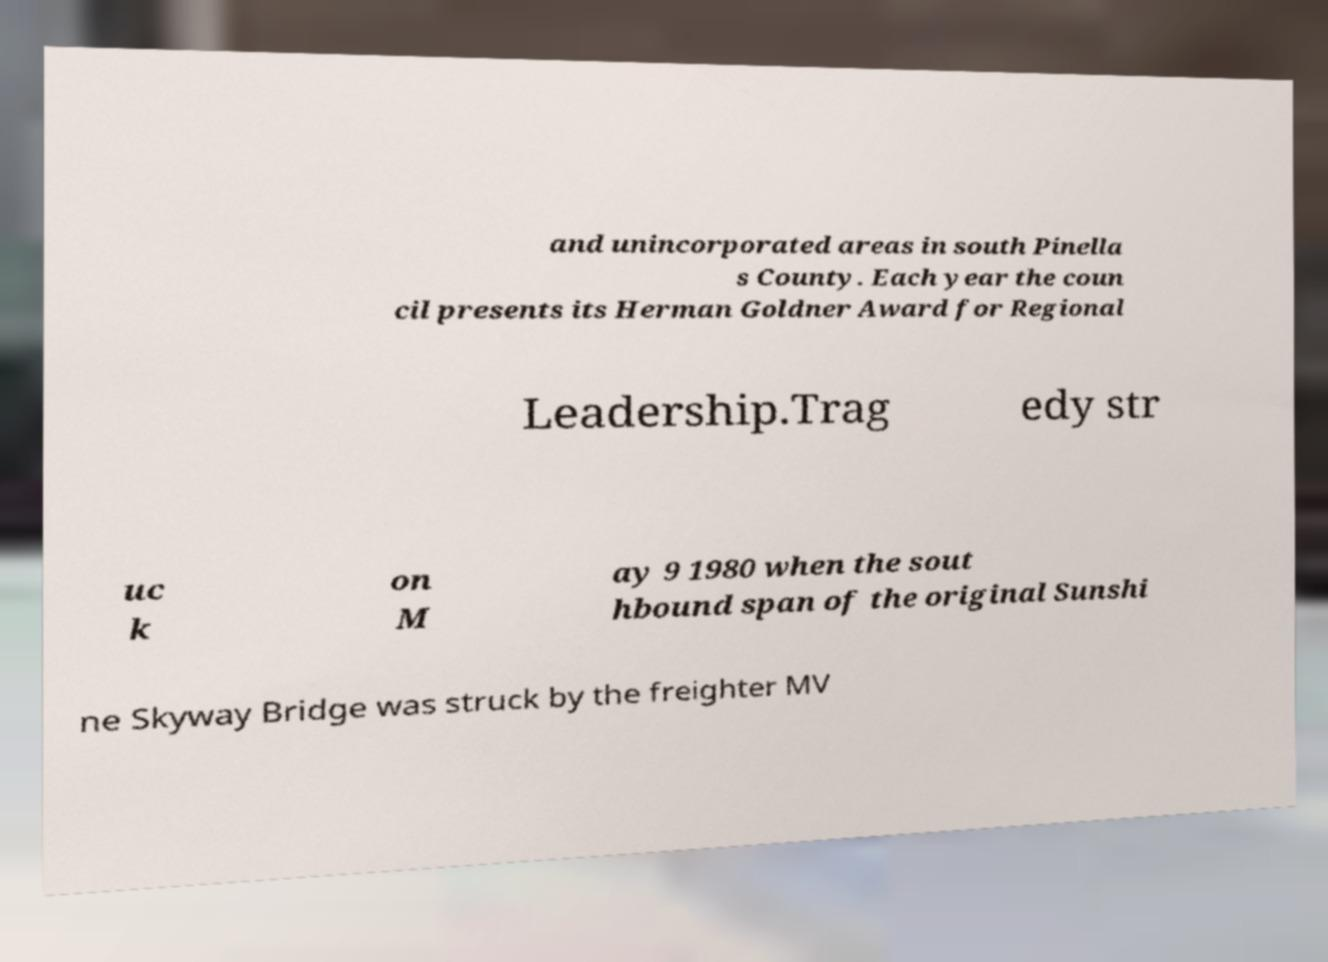Could you assist in decoding the text presented in this image and type it out clearly? and unincorporated areas in south Pinella s County. Each year the coun cil presents its Herman Goldner Award for Regional Leadership.Trag edy str uc k on M ay 9 1980 when the sout hbound span of the original Sunshi ne Skyway Bridge was struck by the freighter MV 